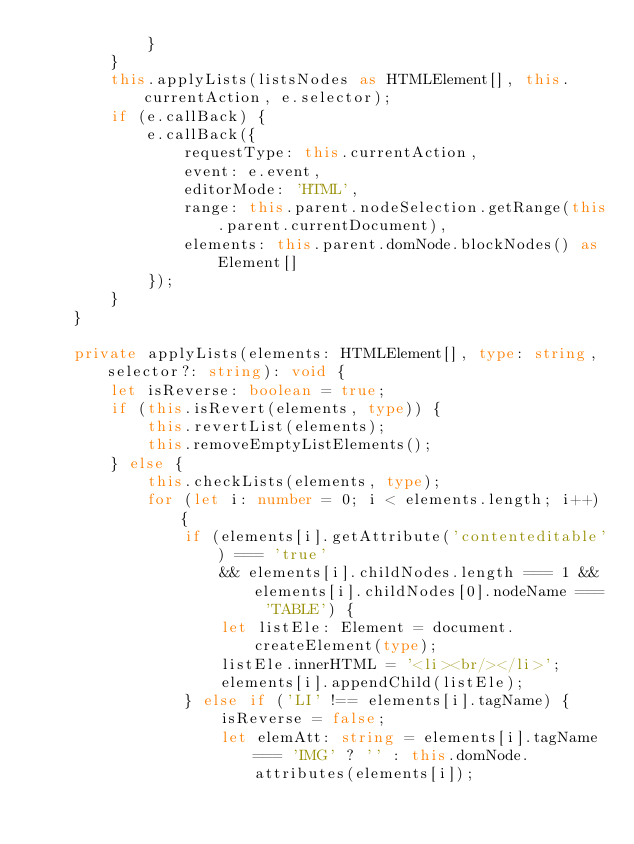Convert code to text. <code><loc_0><loc_0><loc_500><loc_500><_TypeScript_>            }
        }
        this.applyLists(listsNodes as HTMLElement[], this.currentAction, e.selector);
        if (e.callBack) {
            e.callBack({
                requestType: this.currentAction,
                event: e.event,
                editorMode: 'HTML',
                range: this.parent.nodeSelection.getRange(this.parent.currentDocument),
                elements: this.parent.domNode.blockNodes() as Element[]
            });
        }
    }

    private applyLists(elements: HTMLElement[], type: string, selector?: string): void {
        let isReverse: boolean = true;
        if (this.isRevert(elements, type)) {
            this.revertList(elements);
            this.removeEmptyListElements();
        } else {
            this.checkLists(elements, type);
            for (let i: number = 0; i < elements.length; i++) {
                if (elements[i].getAttribute('contenteditable') === 'true'
                    && elements[i].childNodes.length === 1 && elements[i].childNodes[0].nodeName === 'TABLE') {
                    let listEle: Element = document.createElement(type);
                    listEle.innerHTML = '<li><br/></li>';
                    elements[i].appendChild(listEle);
                } else if ('LI' !== elements[i].tagName) {
                    isReverse = false;
                    let elemAtt: string = elements[i].tagName === 'IMG' ? '' : this.domNode.attributes(elements[i]);</code> 